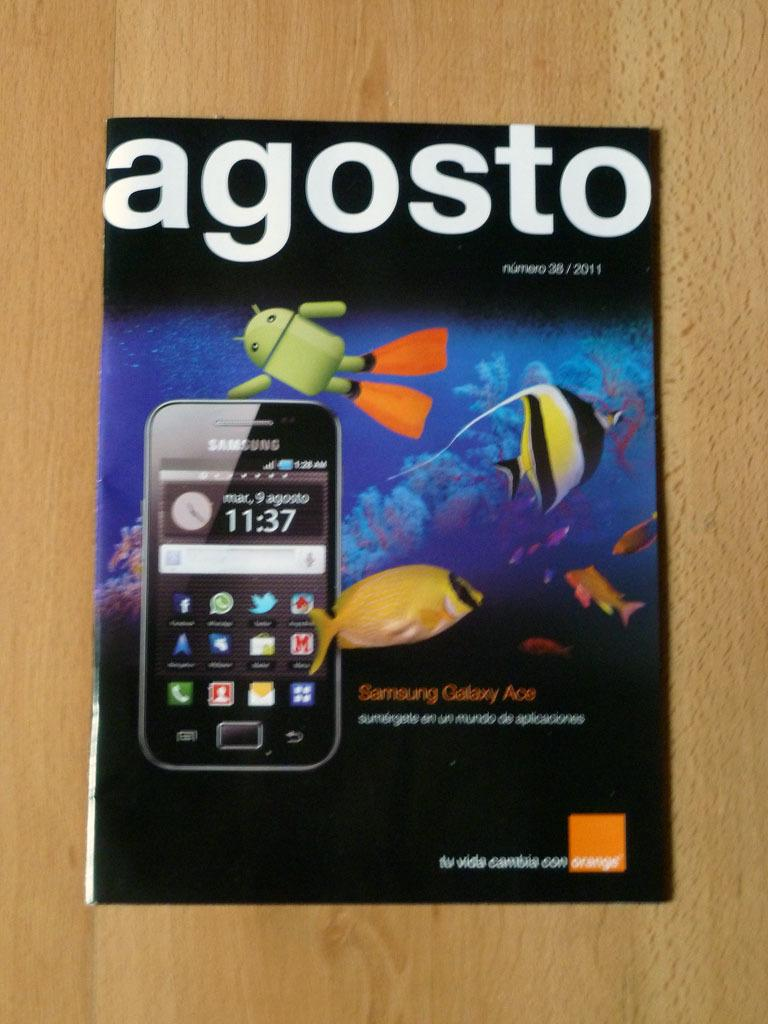<image>
Render a clear and concise summary of the photo. An ad for a Samsung phone says "agosto" at the top. 